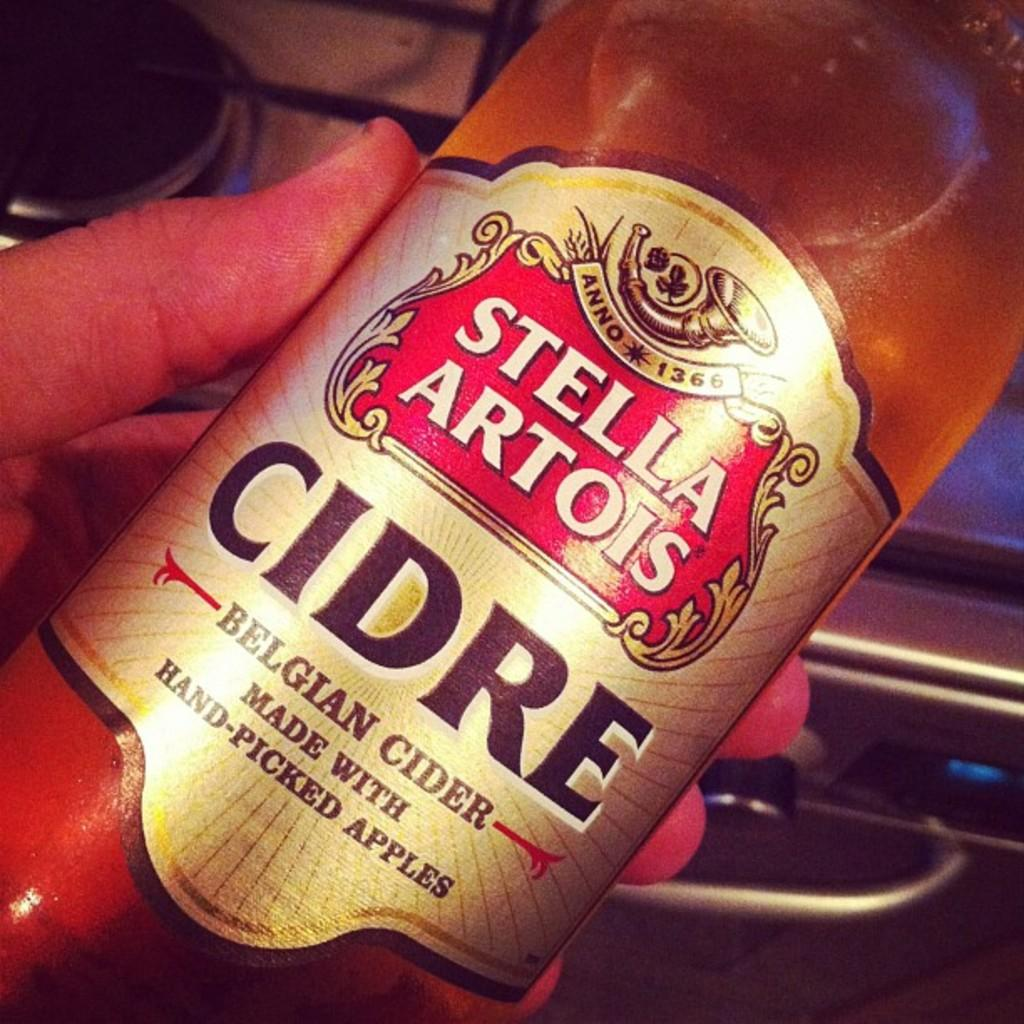What is being held by the hand in the image? There is a bottle in the hand. What can be seen on the bottle? There is a sticker on the bottle. What can be seen in the background of the image? There is a stove, a handle, and a digital screen in the background of the image. How many houses are visible in the image? There are no houses visible in the image. What type of room is the hand in? The image does not provide information about the room or any other surrounding environment. 